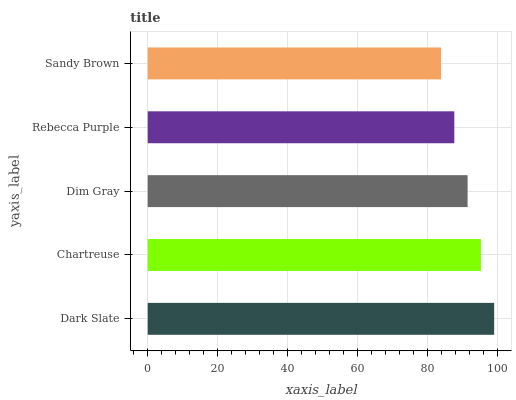Is Sandy Brown the minimum?
Answer yes or no. Yes. Is Dark Slate the maximum?
Answer yes or no. Yes. Is Chartreuse the minimum?
Answer yes or no. No. Is Chartreuse the maximum?
Answer yes or no. No. Is Dark Slate greater than Chartreuse?
Answer yes or no. Yes. Is Chartreuse less than Dark Slate?
Answer yes or no. Yes. Is Chartreuse greater than Dark Slate?
Answer yes or no. No. Is Dark Slate less than Chartreuse?
Answer yes or no. No. Is Dim Gray the high median?
Answer yes or no. Yes. Is Dim Gray the low median?
Answer yes or no. Yes. Is Chartreuse the high median?
Answer yes or no. No. Is Chartreuse the low median?
Answer yes or no. No. 